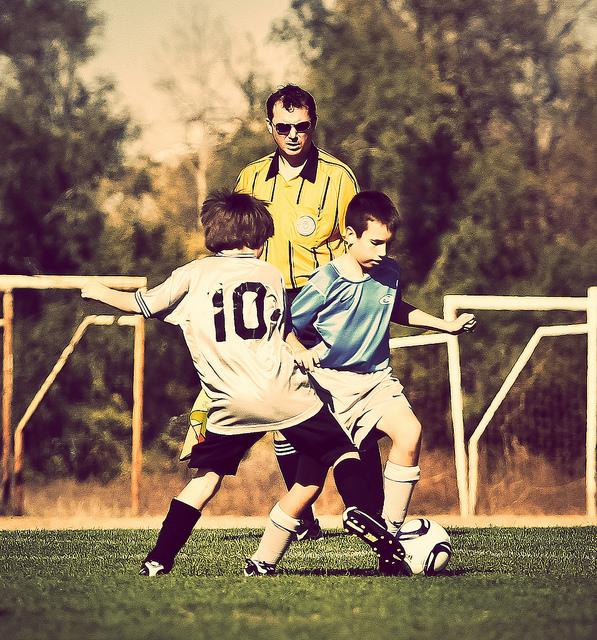What sort of job is the man standing in yellow doing?

Choices:
A) secret shopper
B) game official
C) cheer leader
D) field worker game official 